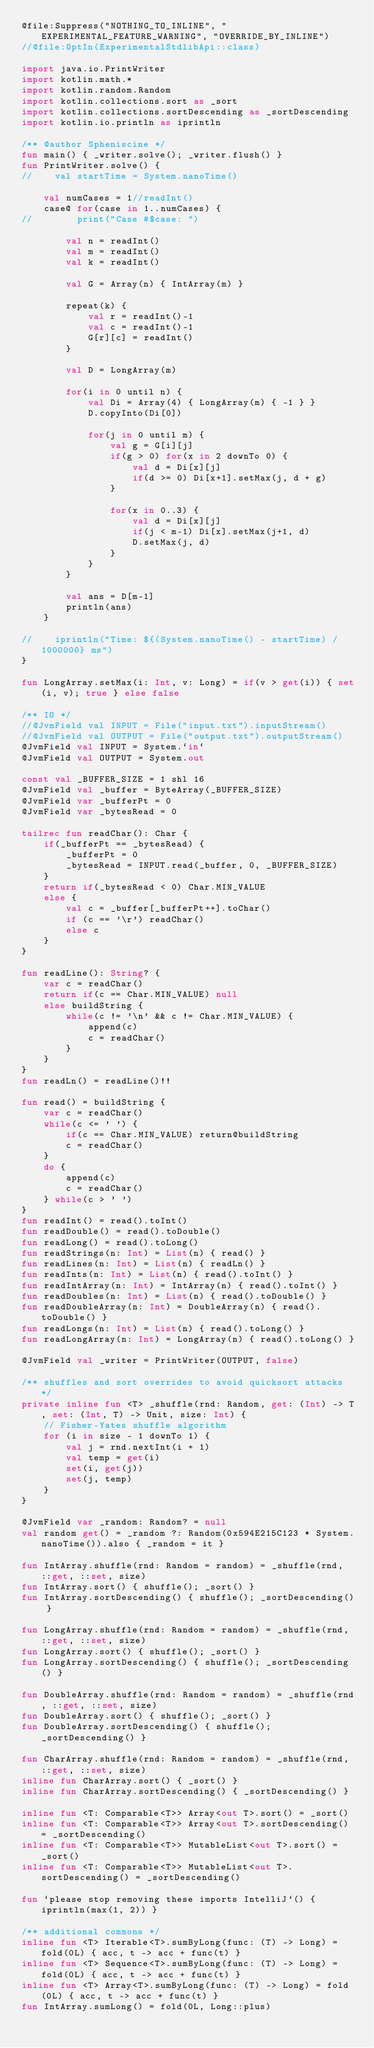Convert code to text. <code><loc_0><loc_0><loc_500><loc_500><_Kotlin_>@file:Suppress("NOTHING_TO_INLINE", "EXPERIMENTAL_FEATURE_WARNING", "OVERRIDE_BY_INLINE")
//@file:OptIn(ExperimentalStdlibApi::class)

import java.io.PrintWriter
import kotlin.math.*
import kotlin.random.Random
import kotlin.collections.sort as _sort
import kotlin.collections.sortDescending as _sortDescending
import kotlin.io.println as iprintln

/** @author Spheniscine */
fun main() { _writer.solve(); _writer.flush() }
fun PrintWriter.solve() {
//    val startTime = System.nanoTime()

    val numCases = 1//readInt()
    case@ for(case in 1..numCases) {
//        print("Case #$case: ")

        val n = readInt()
        val m = readInt()
        val k = readInt()

        val G = Array(n) { IntArray(m) }

        repeat(k) {
            val r = readInt()-1
            val c = readInt()-1
            G[r][c] = readInt()
        }

        val D = LongArray(m)

        for(i in 0 until n) {
            val Di = Array(4) { LongArray(m) { -1 } }
            D.copyInto(Di[0])

            for(j in 0 until m) {
                val g = G[i][j]
                if(g > 0) for(x in 2 downTo 0) {
                    val d = Di[x][j]
                    if(d >= 0) Di[x+1].setMax(j, d + g)
                }

                for(x in 0..3) {
                    val d = Di[x][j]
                    if(j < m-1) Di[x].setMax(j+1, d)
                    D.setMax(j, d)
                }
            }
        }

        val ans = D[m-1]
        println(ans)
    }

//    iprintln("Time: ${(System.nanoTime() - startTime) / 1000000} ms")
}

fun LongArray.setMax(i: Int, v: Long) = if(v > get(i)) { set(i, v); true } else false

/** IO */
//@JvmField val INPUT = File("input.txt").inputStream()
//@JvmField val OUTPUT = File("output.txt").outputStream()
@JvmField val INPUT = System.`in`
@JvmField val OUTPUT = System.out

const val _BUFFER_SIZE = 1 shl 16
@JvmField val _buffer = ByteArray(_BUFFER_SIZE)
@JvmField var _bufferPt = 0
@JvmField var _bytesRead = 0

tailrec fun readChar(): Char {
    if(_bufferPt == _bytesRead) {
        _bufferPt = 0
        _bytesRead = INPUT.read(_buffer, 0, _BUFFER_SIZE)
    }
    return if(_bytesRead < 0) Char.MIN_VALUE
    else {
        val c = _buffer[_bufferPt++].toChar()
        if (c == '\r') readChar()
        else c
    }
}

fun readLine(): String? {
    var c = readChar()
    return if(c == Char.MIN_VALUE) null
    else buildString {
        while(c != '\n' && c != Char.MIN_VALUE) {
            append(c)
            c = readChar()
        }
    }
}
fun readLn() = readLine()!!

fun read() = buildString {
    var c = readChar()
    while(c <= ' ') {
        if(c == Char.MIN_VALUE) return@buildString
        c = readChar()
    }
    do {
        append(c)
        c = readChar()
    } while(c > ' ')
}
fun readInt() = read().toInt()
fun readDouble() = read().toDouble()
fun readLong() = read().toLong()
fun readStrings(n: Int) = List(n) { read() }
fun readLines(n: Int) = List(n) { readLn() }
fun readInts(n: Int) = List(n) { read().toInt() }
fun readIntArray(n: Int) = IntArray(n) { read().toInt() }
fun readDoubles(n: Int) = List(n) { read().toDouble() }
fun readDoubleArray(n: Int) = DoubleArray(n) { read().toDouble() }
fun readLongs(n: Int) = List(n) { read().toLong() }
fun readLongArray(n: Int) = LongArray(n) { read().toLong() }

@JvmField val _writer = PrintWriter(OUTPUT, false)

/** shuffles and sort overrides to avoid quicksort attacks */
private inline fun <T> _shuffle(rnd: Random, get: (Int) -> T, set: (Int, T) -> Unit, size: Int) {
    // Fisher-Yates shuffle algorithm
    for (i in size - 1 downTo 1) {
        val j = rnd.nextInt(i + 1)
        val temp = get(i)
        set(i, get(j))
        set(j, temp)
    }
}

@JvmField var _random: Random? = null
val random get() = _random ?: Random(0x594E215C123 * System.nanoTime()).also { _random = it }

fun IntArray.shuffle(rnd: Random = random) = _shuffle(rnd, ::get, ::set, size)
fun IntArray.sort() { shuffle(); _sort() }
fun IntArray.sortDescending() { shuffle(); _sortDescending() }

fun LongArray.shuffle(rnd: Random = random) = _shuffle(rnd, ::get, ::set, size)
fun LongArray.sort() { shuffle(); _sort() }
fun LongArray.sortDescending() { shuffle(); _sortDescending() }

fun DoubleArray.shuffle(rnd: Random = random) = _shuffle(rnd, ::get, ::set, size)
fun DoubleArray.sort() { shuffle(); _sort() }
fun DoubleArray.sortDescending() { shuffle(); _sortDescending() }

fun CharArray.shuffle(rnd: Random = random) = _shuffle(rnd, ::get, ::set, size)
inline fun CharArray.sort() { _sort() }
inline fun CharArray.sortDescending() { _sortDescending() }

inline fun <T: Comparable<T>> Array<out T>.sort() = _sort()
inline fun <T: Comparable<T>> Array<out T>.sortDescending() = _sortDescending()
inline fun <T: Comparable<T>> MutableList<out T>.sort() = _sort()
inline fun <T: Comparable<T>> MutableList<out T>.sortDescending() = _sortDescending()

fun `please stop removing these imports IntelliJ`() { iprintln(max(1, 2)) }

/** additional commons */
inline fun <T> Iterable<T>.sumByLong(func: (T) -> Long) = fold(0L) { acc, t -> acc + func(t) }
inline fun <T> Sequence<T>.sumByLong(func: (T) -> Long) = fold(0L) { acc, t -> acc + func(t) }
inline fun <T> Array<T>.sumByLong(func: (T) -> Long) = fold(0L) { acc, t -> acc + func(t) }
fun IntArray.sumLong() = fold(0L, Long::plus)
</code> 